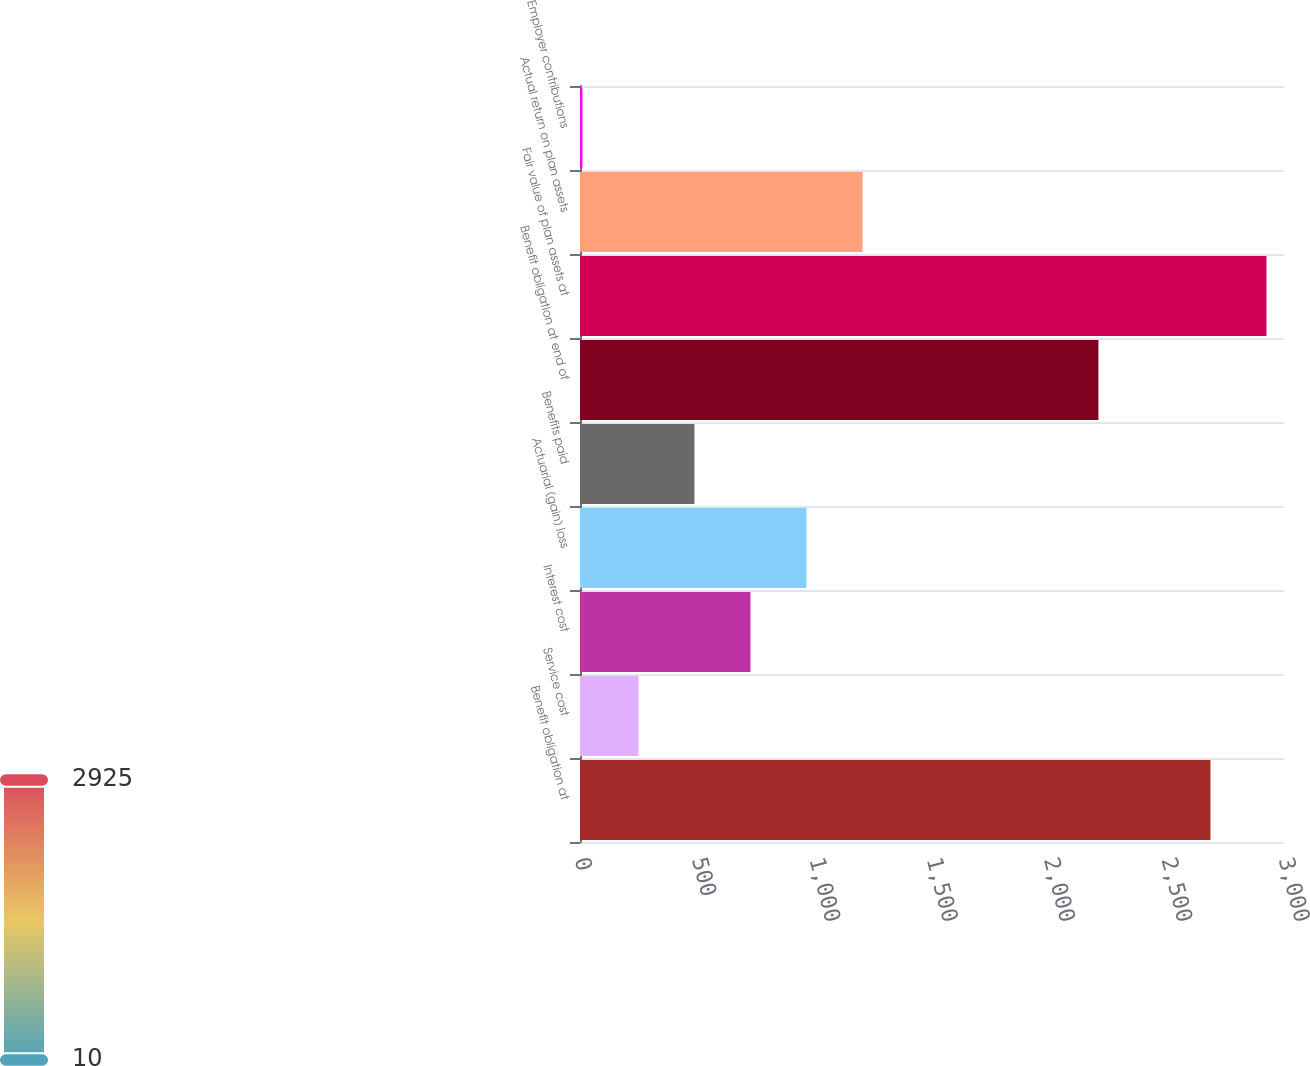<chart> <loc_0><loc_0><loc_500><loc_500><bar_chart><fcel>Benefit obligation at<fcel>Service cost<fcel>Interest cost<fcel>Actuarial (gain) loss<fcel>Benefits paid<fcel>Benefit obligation at end of<fcel>Fair value of plan assets at<fcel>Actual return on plan assets<fcel>Employer contributions<nl><fcel>2686.62<fcel>249.11<fcel>726.53<fcel>965.24<fcel>487.82<fcel>2209.2<fcel>2925.33<fcel>1203.95<fcel>10.4<nl></chart> 